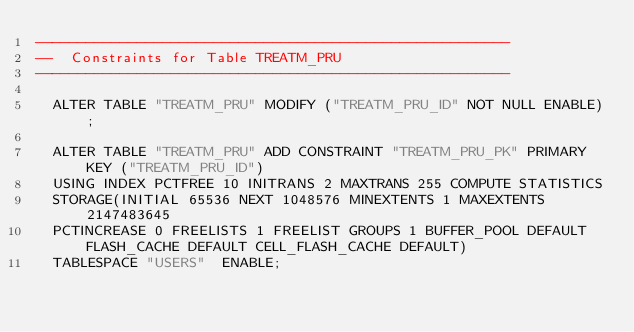Convert code to text. <code><loc_0><loc_0><loc_500><loc_500><_SQL_>--------------------------------------------------------
--  Constraints for Table TREATM_PRU
--------------------------------------------------------

  ALTER TABLE "TREATM_PRU" MODIFY ("TREATM_PRU_ID" NOT NULL ENABLE);
 
  ALTER TABLE "TREATM_PRU" ADD CONSTRAINT "TREATM_PRU_PK" PRIMARY KEY ("TREATM_PRU_ID")
  USING INDEX PCTFREE 10 INITRANS 2 MAXTRANS 255 COMPUTE STATISTICS 
  STORAGE(INITIAL 65536 NEXT 1048576 MINEXTENTS 1 MAXEXTENTS 2147483645
  PCTINCREASE 0 FREELISTS 1 FREELIST GROUPS 1 BUFFER_POOL DEFAULT FLASH_CACHE DEFAULT CELL_FLASH_CACHE DEFAULT)
  TABLESPACE "USERS"  ENABLE;
</code> 